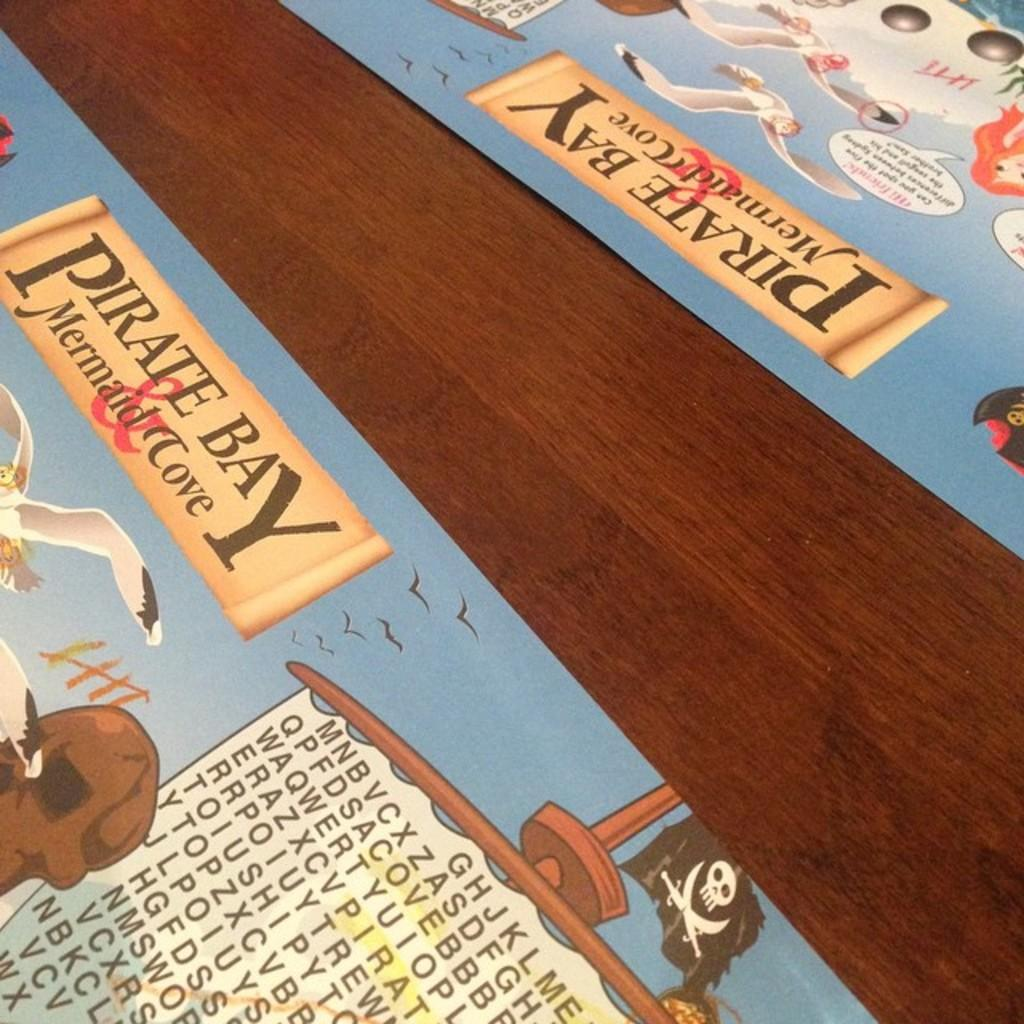Provide a one-sentence caption for the provided image. A wooden table with two Pirate Bay Mermaid Cove place mats on it. 